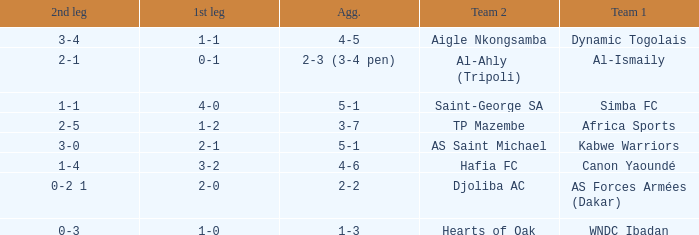What team played against Hafia FC (team 2)? Canon Yaoundé. Parse the full table. {'header': ['2nd leg', '1st leg', 'Agg.', 'Team 2', 'Team 1'], 'rows': [['3-4', '1-1', '4-5', 'Aigle Nkongsamba', 'Dynamic Togolais'], ['2-1', '0-1', '2-3 (3-4 pen)', 'Al-Ahly (Tripoli)', 'Al-Ismaily'], ['1-1', '4-0', '5-1', 'Saint-George SA', 'Simba FC'], ['2-5', '1-2', '3-7', 'TP Mazembe', 'Africa Sports'], ['3-0', '2-1', '5-1', 'AS Saint Michael', 'Kabwe Warriors'], ['1-4', '3-2', '4-6', 'Hafia FC', 'Canon Yaoundé'], ['0-2 1', '2-0', '2-2', 'Djoliba AC', 'AS Forces Armées (Dakar)'], ['0-3', '1-0', '1-3', 'Hearts of Oak', 'WNDC Ibadan']]} 